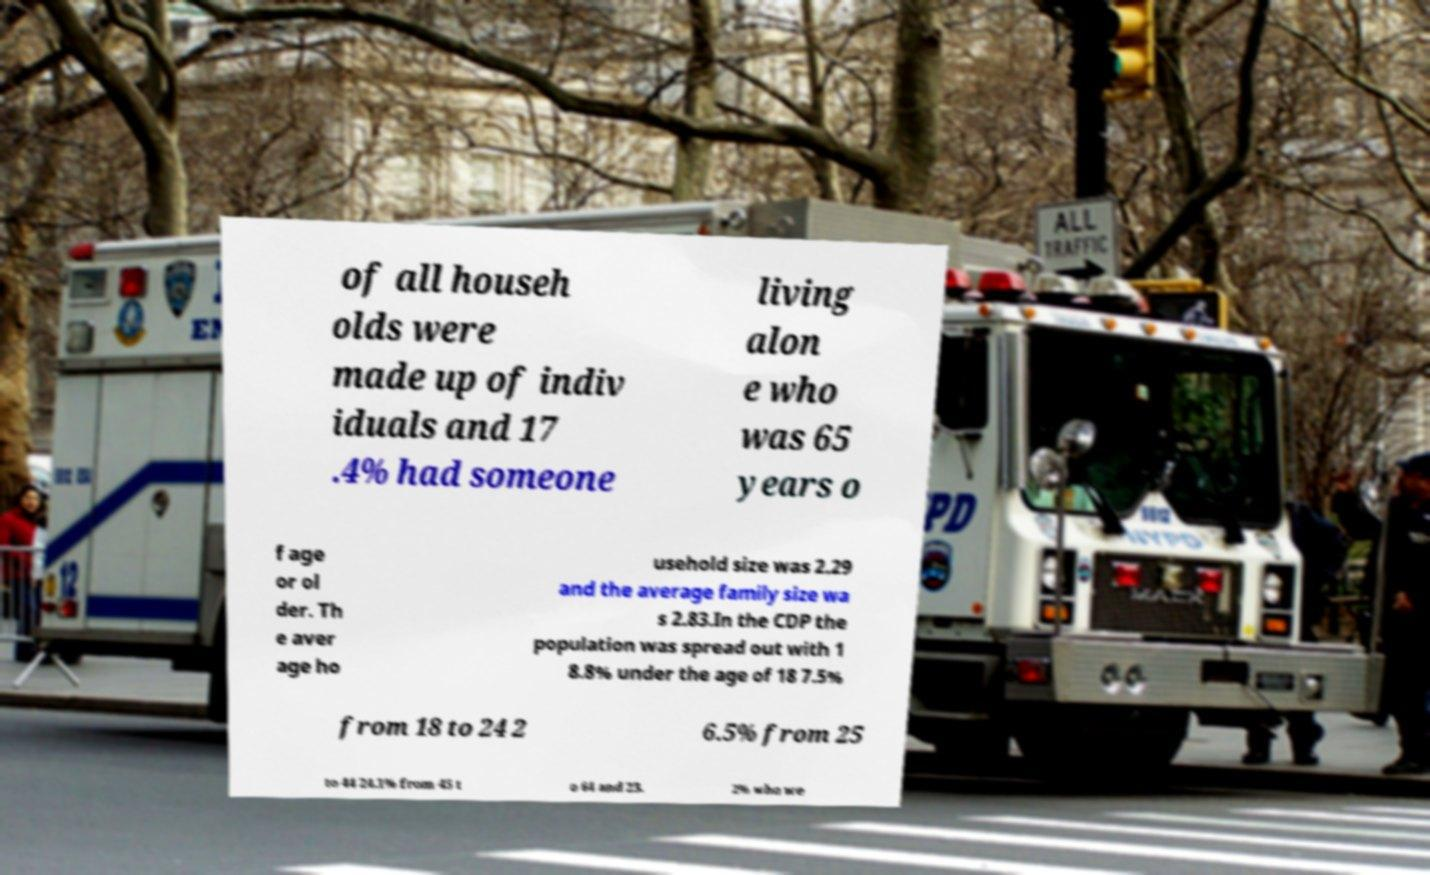Could you extract and type out the text from this image? of all househ olds were made up of indiv iduals and 17 .4% had someone living alon e who was 65 years o f age or ol der. Th e aver age ho usehold size was 2.29 and the average family size wa s 2.83.In the CDP the population was spread out with 1 8.8% under the age of 18 7.5% from 18 to 24 2 6.5% from 25 to 44 24.1% from 45 t o 64 and 23. 2% who we 